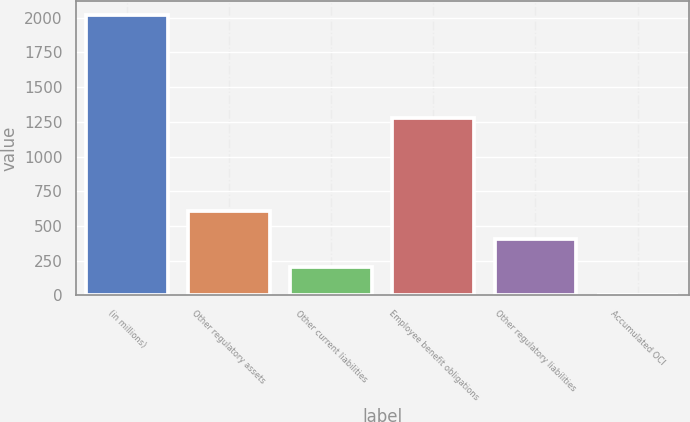<chart> <loc_0><loc_0><loc_500><loc_500><bar_chart><fcel>(in millions)<fcel>Other regulatory assets<fcel>Other current liabilities<fcel>Employee benefit obligations<fcel>Other regulatory liabilities<fcel>Accumulated OCI<nl><fcel>2017<fcel>607.9<fcel>205.3<fcel>1281<fcel>406.6<fcel>4<nl></chart> 